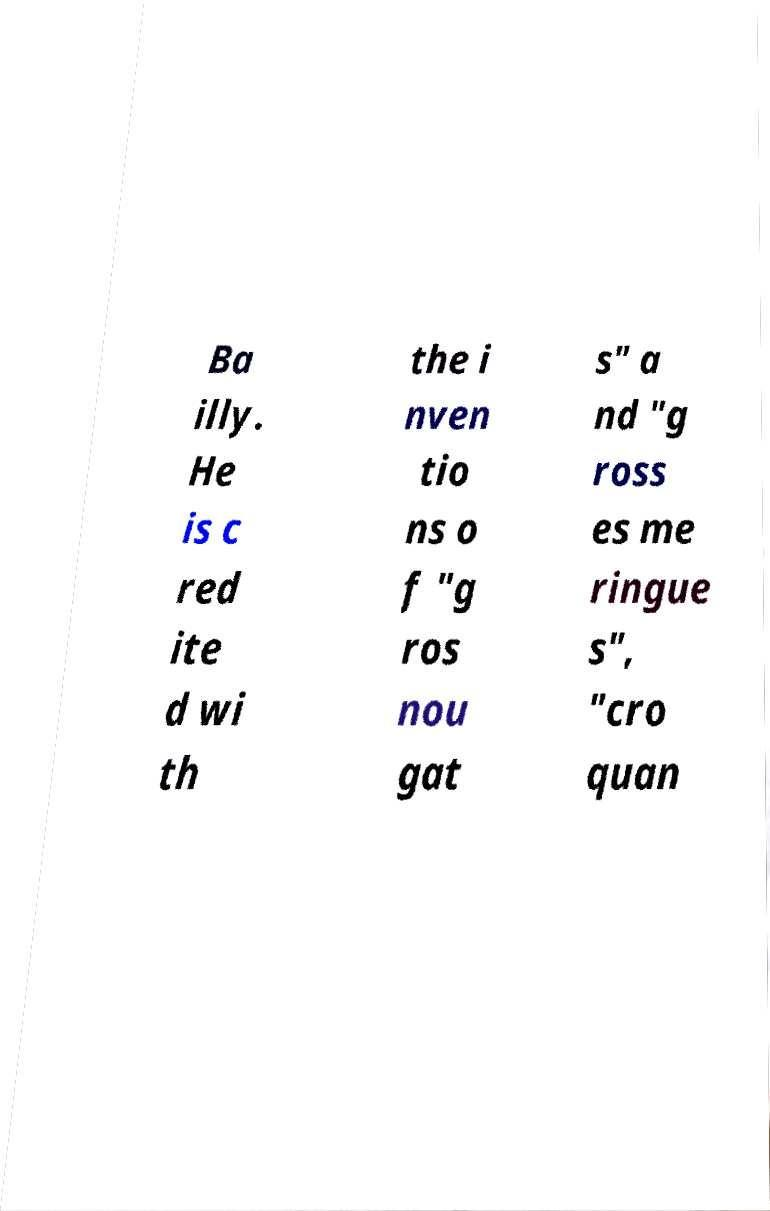I need the written content from this picture converted into text. Can you do that? Ba illy. He is c red ite d wi th the i nven tio ns o f "g ros nou gat s" a nd "g ross es me ringue s", "cro quan 